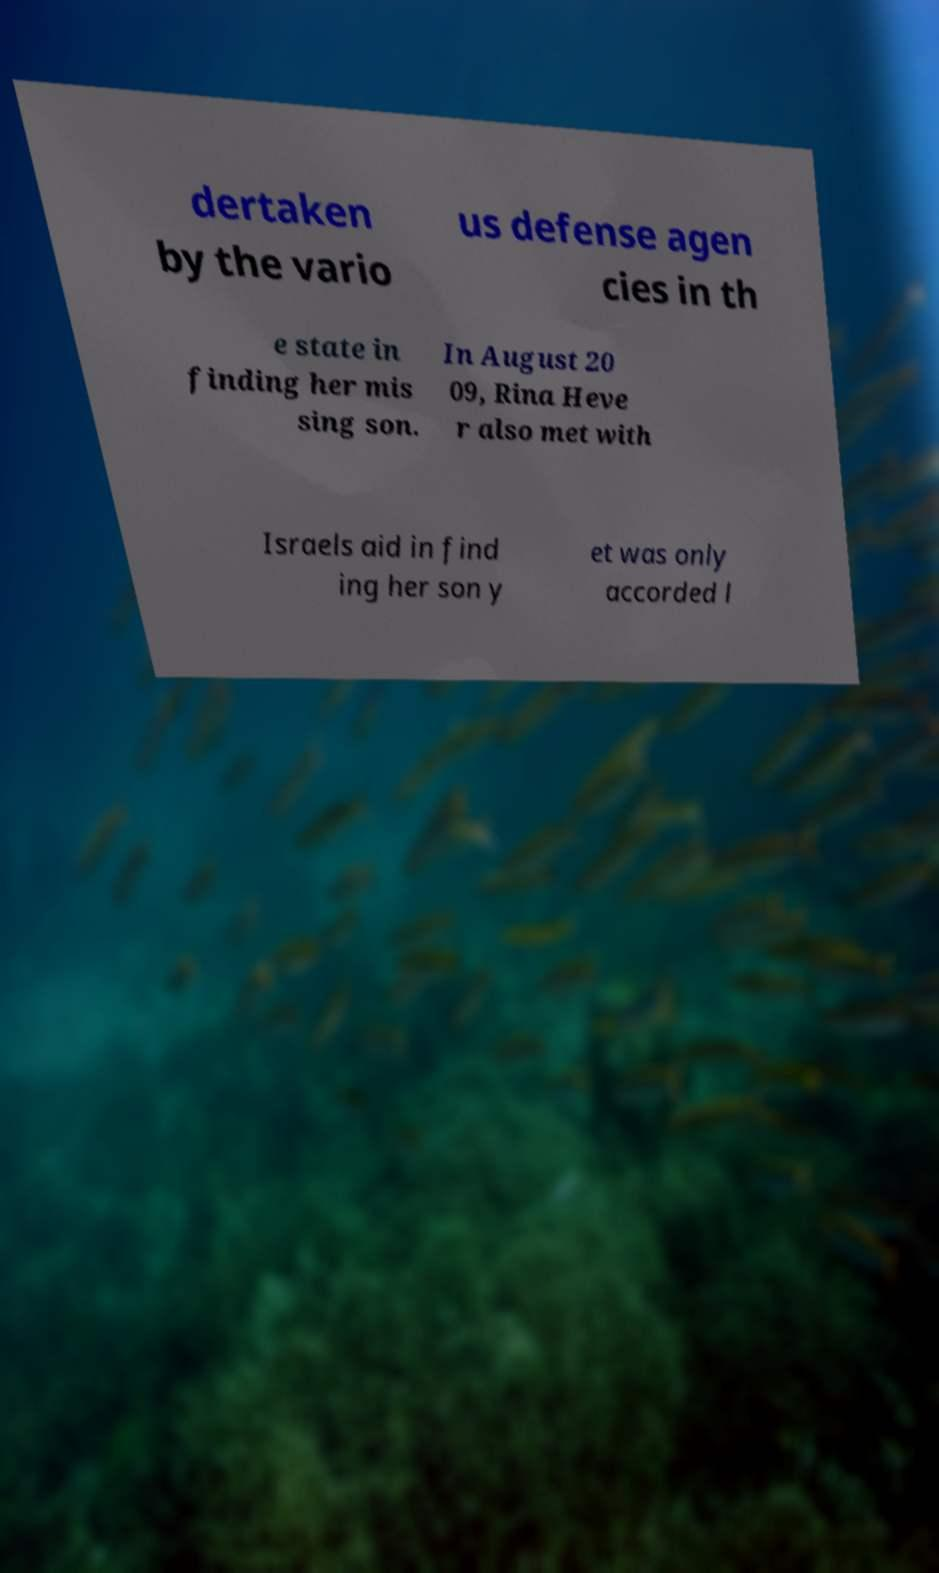For documentation purposes, I need the text within this image transcribed. Could you provide that? dertaken by the vario us defense agen cies in th e state in finding her mis sing son. In August 20 09, Rina Heve r also met with Israels aid in find ing her son y et was only accorded l 